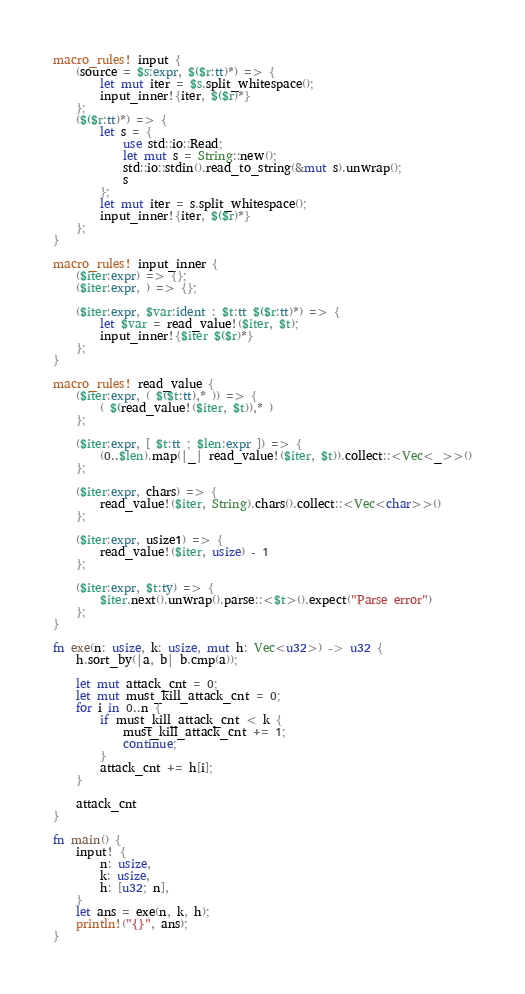<code> <loc_0><loc_0><loc_500><loc_500><_Rust_>macro_rules! input {
    (source = $s:expr, $($r:tt)*) => {
        let mut iter = $s.split_whitespace();
        input_inner!{iter, $($r)*}
    };
    ($($r:tt)*) => {
        let s = {
            use std::io::Read;
            let mut s = String::new();
            std::io::stdin().read_to_string(&mut s).unwrap();
            s
        };
        let mut iter = s.split_whitespace();
        input_inner!{iter, $($r)*}
    };
}

macro_rules! input_inner {
    ($iter:expr) => {};
    ($iter:expr, ) => {};

    ($iter:expr, $var:ident : $t:tt $($r:tt)*) => {
        let $var = read_value!($iter, $t);
        input_inner!{$iter $($r)*}
    };
}

macro_rules! read_value {
    ($iter:expr, ( $($t:tt),* )) => {
        ( $(read_value!($iter, $t)),* )
    };

    ($iter:expr, [ $t:tt ; $len:expr ]) => {
        (0..$len).map(|_| read_value!($iter, $t)).collect::<Vec<_>>()
    };

    ($iter:expr, chars) => {
        read_value!($iter, String).chars().collect::<Vec<char>>()
    };

    ($iter:expr, usize1) => {
        read_value!($iter, usize) - 1
    };

    ($iter:expr, $t:ty) => {
        $iter.next().unwrap().parse::<$t>().expect("Parse error")
    };
}

fn exe(n: usize, k: usize, mut h: Vec<u32>) -> u32 {
    h.sort_by(|a, b| b.cmp(a));

    let mut attack_cnt = 0;
    let mut must_kill_attack_cnt = 0;
    for i in 0..n {
        if must_kill_attack_cnt < k {
            must_kill_attack_cnt += 1;
            continue;
        }
        attack_cnt += h[i];
    }

    attack_cnt
}

fn main() {
    input! {
        n: usize,
        k: usize,
        h: [u32; n],
    }
    let ans = exe(n, k, h);
    println!("{}", ans);
}
</code> 